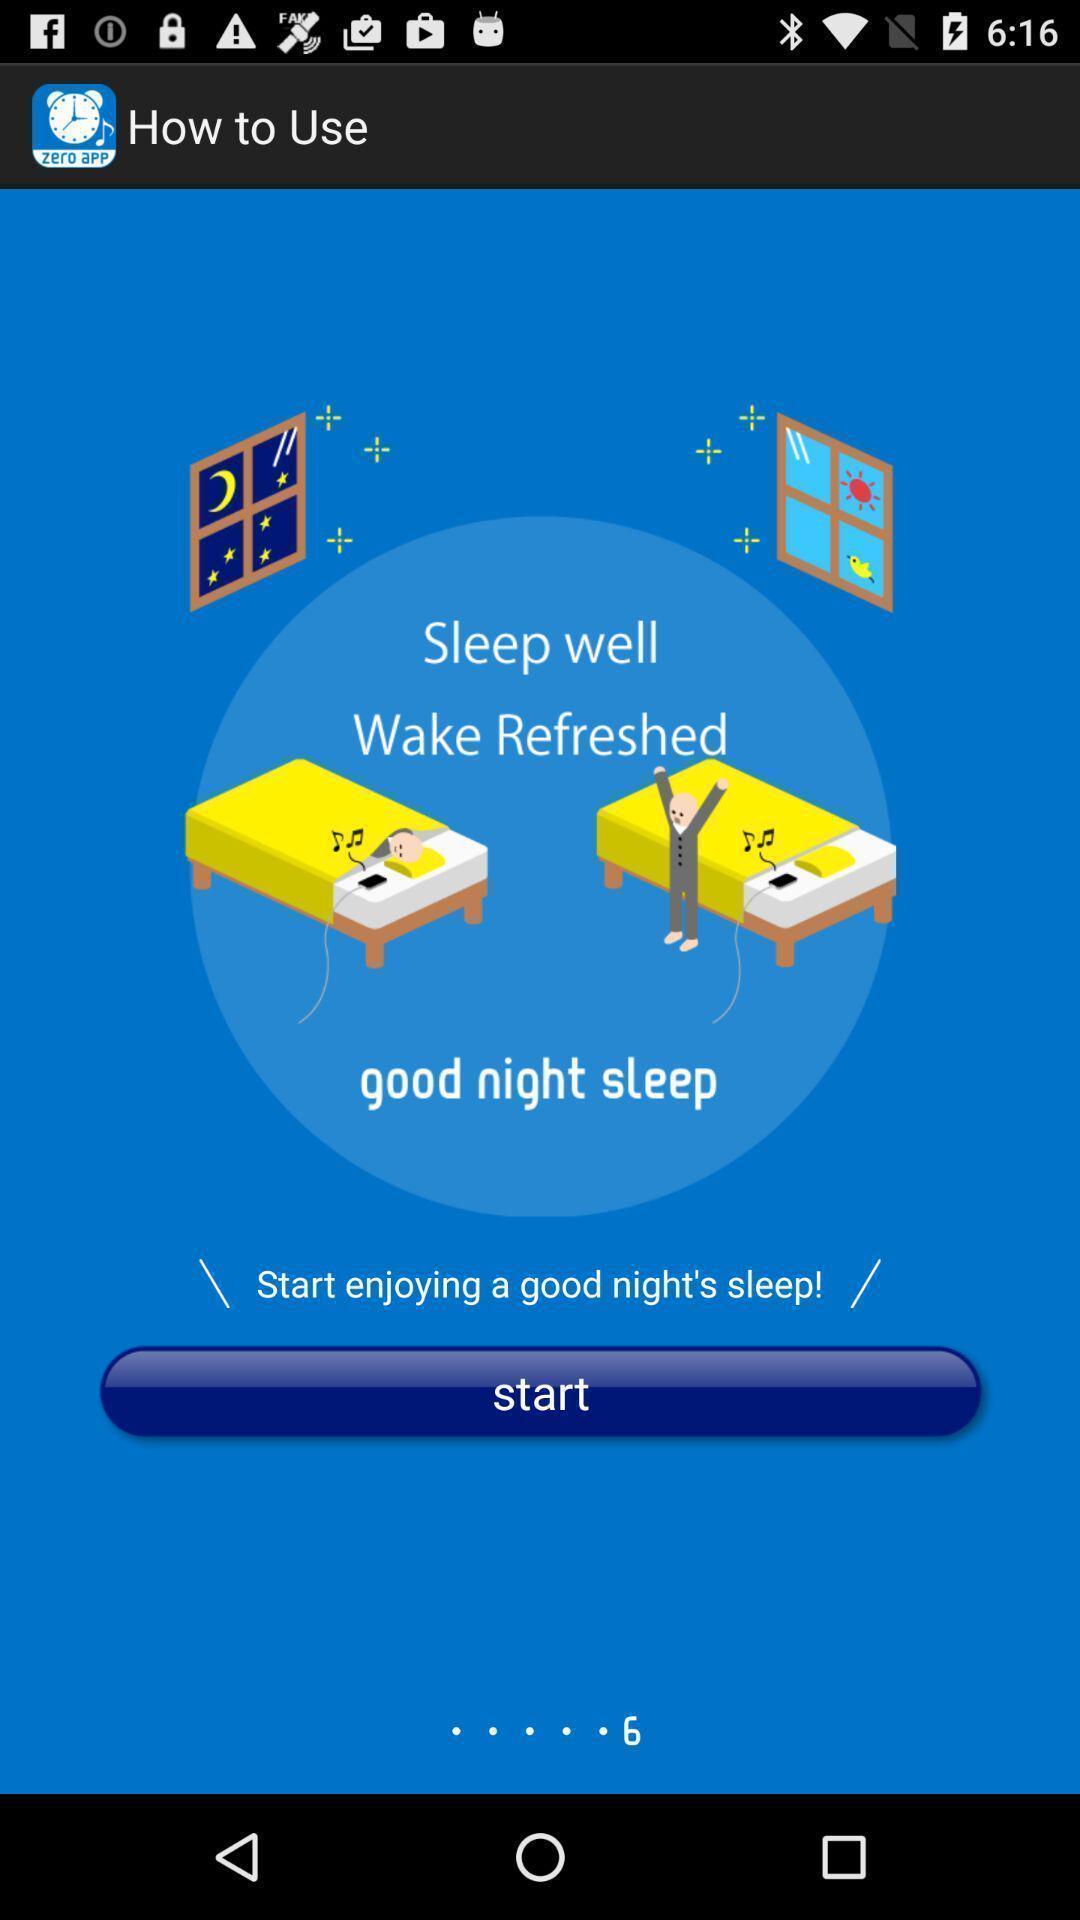Give me a summary of this screen capture. Welcome page of sleep tracking app. 